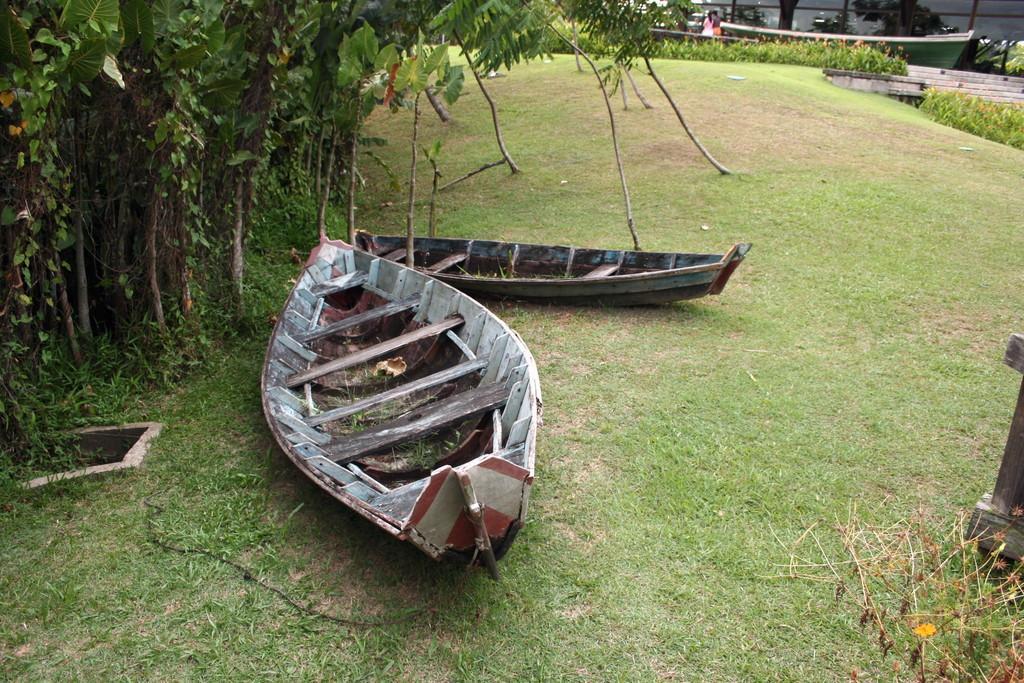Could you give a brief overview of what you see in this image? In this picture we can see few boats on the grass, beside to the boats we can find trees, in the background we can see few people. 